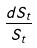Convert formula to latex. <formula><loc_0><loc_0><loc_500><loc_500>\frac { d S _ { t } } { S _ { t } }</formula> 